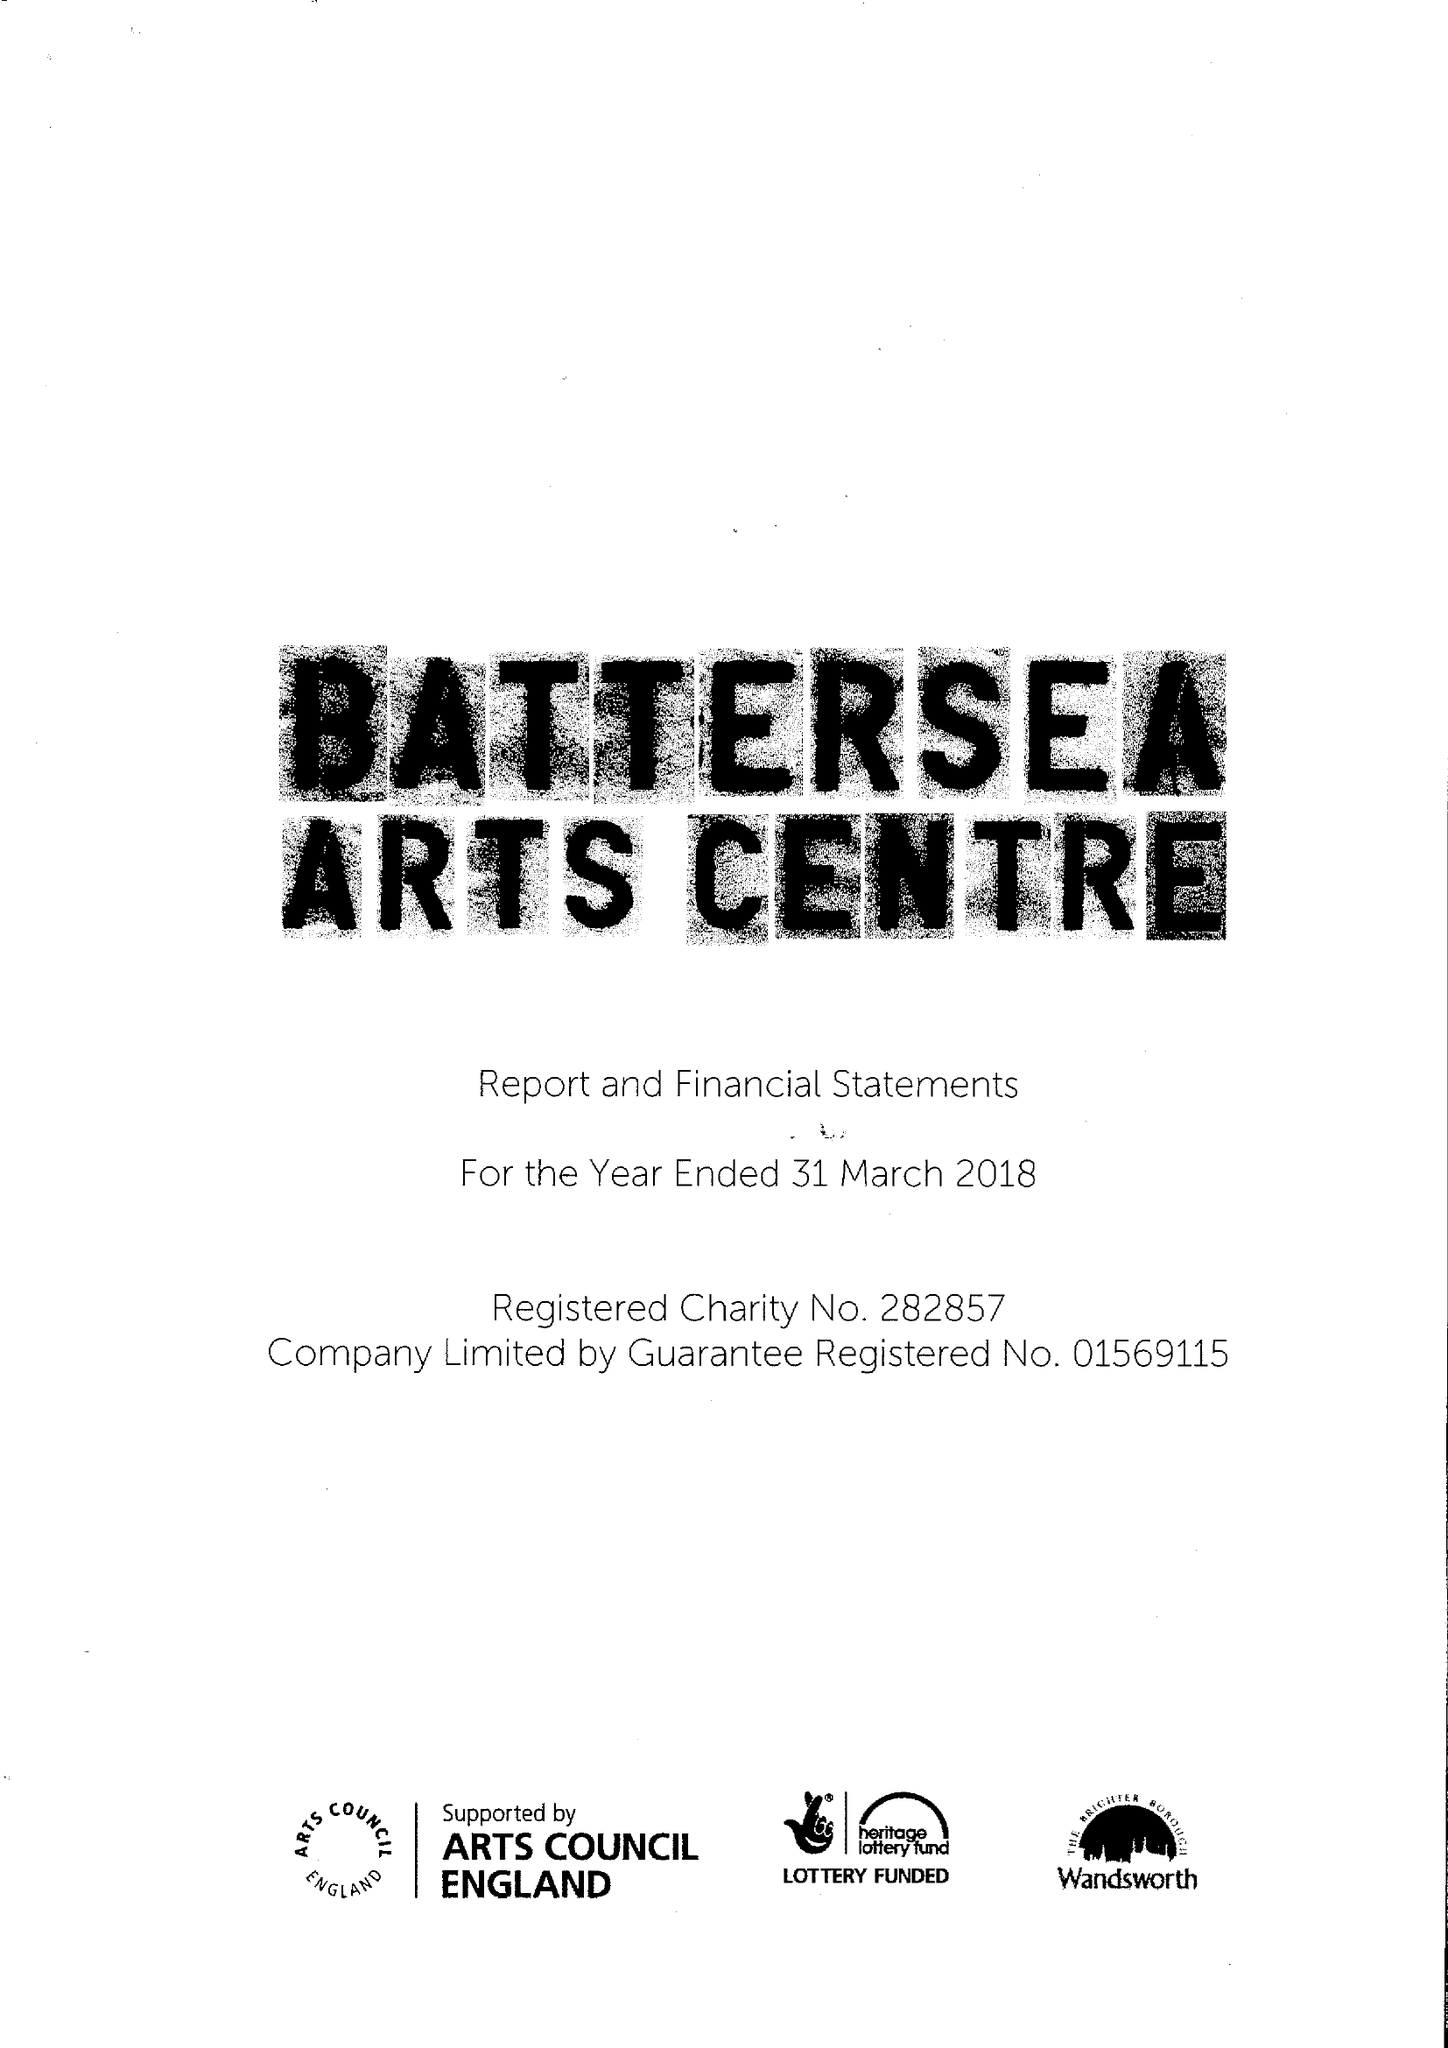What is the value for the address__street_line?
Answer the question using a single word or phrase. LAVENDER HILL 